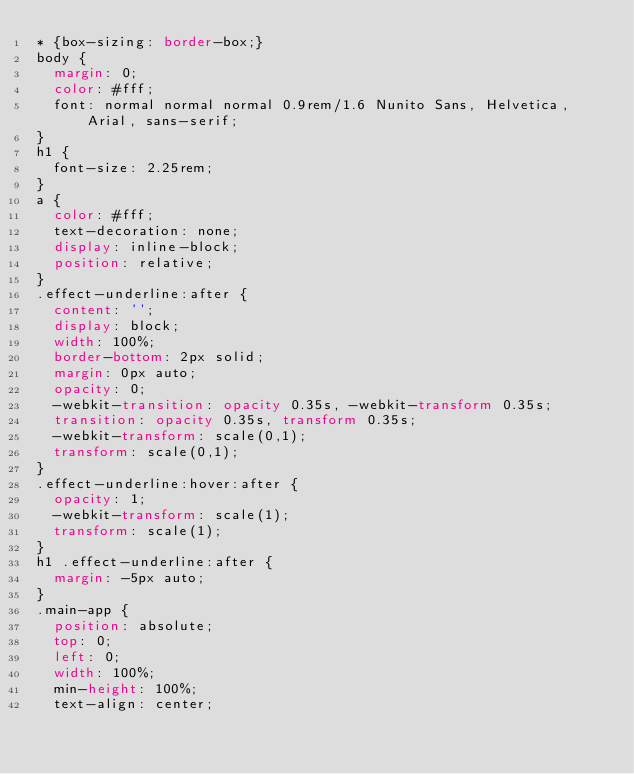Convert code to text. <code><loc_0><loc_0><loc_500><loc_500><_CSS_>* {box-sizing: border-box;}
body {
  margin: 0;
  color: #fff;
  font: normal normal normal 0.9rem/1.6 Nunito Sans, Helvetica, Arial, sans-serif;
}
h1 { 
  font-size: 2.25rem;
}
a {
  color: #fff;
  text-decoration: none;
  display: inline-block;
  position: relative;
}
.effect-underline:after {
	content: '';
  display: block;
  width: 100%;
  border-bottom: 2px solid;
  margin: 0px auto;
  opacity: 0;
	-webkit-transition: opacity 0.35s, -webkit-transform 0.35s;
	transition: opacity 0.35s, transform 0.35s;
	-webkit-transform: scale(0,1);
	transform: scale(0,1);
}
.effect-underline:hover:after {
  opacity: 1;
	-webkit-transform: scale(1);
	transform: scale(1);
}
h1 .effect-underline:after {
  margin: -5px auto;
}
.main-app {
  position: absolute;
  top: 0;
  left: 0;
  width: 100%;
  min-height: 100%;
  text-align: center;</code> 